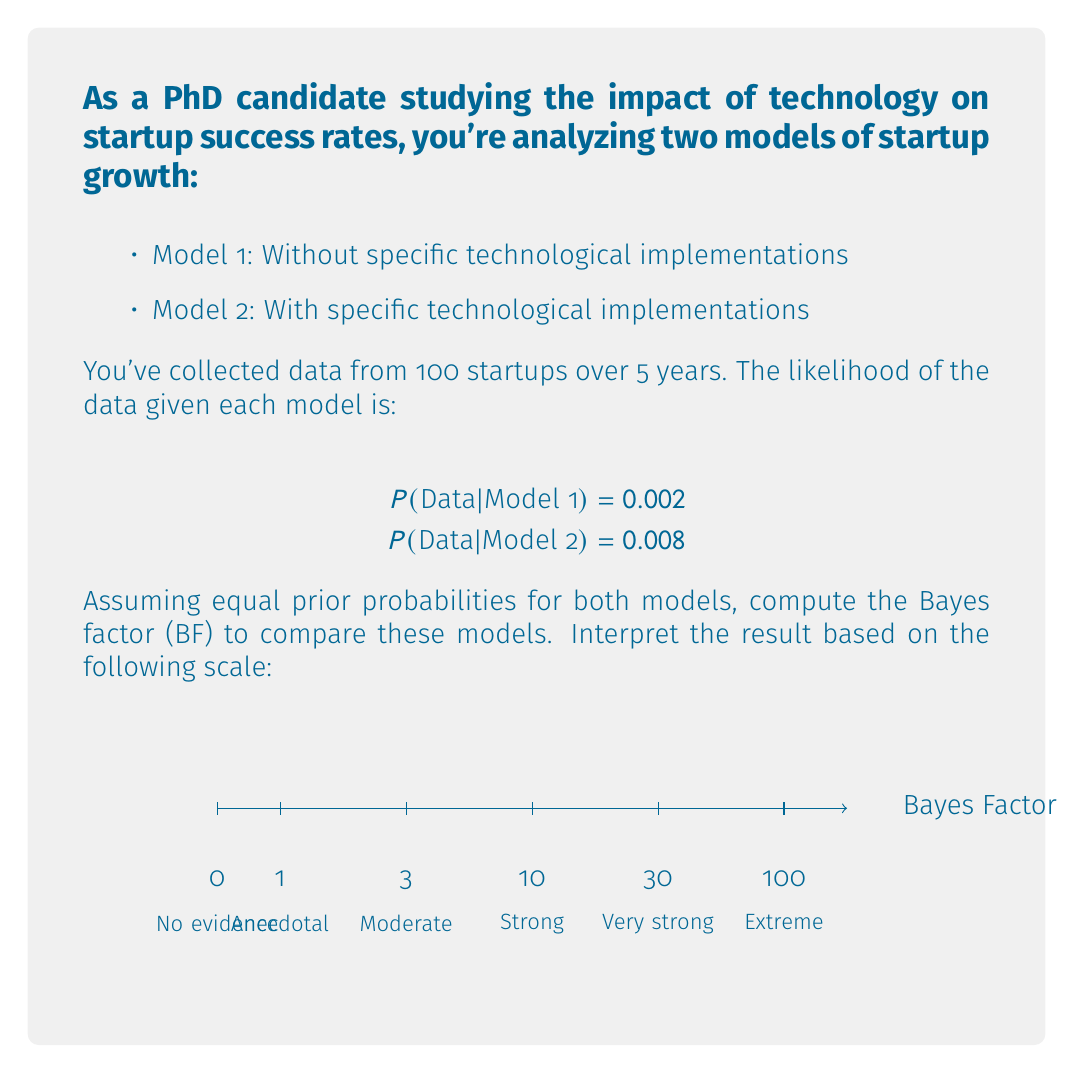What is the answer to this math problem? To solve this problem, we'll follow these steps:

1) Recall the formula for the Bayes factor:

   $BF = \frac{P(\text{Data}|\text{Model 2})}{P(\text{Data}|\text{Model 1})}$

2) We're given:
   $P(\text{Data}|\text{Model 1}) = 0.002$
   $P(\text{Data}|\text{Model 2}) = 0.008$

3) Substitute these values into the Bayes factor formula:

   $BF = \frac{0.008}{0.002}$

4) Simplify:
   $BF = 4$

5) Interpret the result:
   A Bayes factor of 4 falls in the "Moderate" evidence category on the provided scale. This suggests that the data provides moderate evidence in favor of Model 2 (with specific technological implementations) over Model 1 (without specific technological implementations).

   In other words, the data is 4 times more likely under the model that includes specific technological implementations compared to the model without them.
Answer: $BF = 4$ (Moderate evidence for Model 2) 